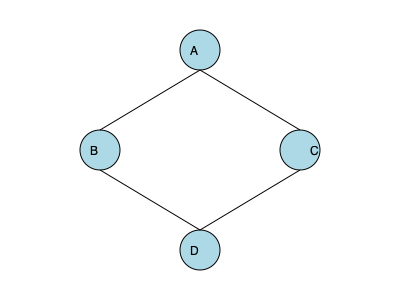Which network topology is represented in the diagram above, and how might it be beneficial for secure transmission of sensitive medical data? To identify the network topology and understand its benefits for secure medical data transmission, let's follow these steps:

1. Observe the diagram:
   - There are four nodes (A, B, C, and D) connected by lines.
   - The connections form a diamond shape.

2. Identify the topology:
   - This is a Ring topology, where each node is connected to exactly two other nodes, forming a closed loop.

3. Characteristics of a Ring topology:
   - Data travels in one direction around the ring.
   - Each node acts as a repeater, boosting the signal.

4. Benefits for secure medical data transmission:
   a) Redundancy: If one connection fails, data can still reach its destination through the other direction.
   b) Predictable performance: Each node gets an equal opportunity to transmit, ensuring consistent data flow.
   c) No central point of failure: Unlike star topologies, there's no central hub that could compromise the entire network if it fails.
   d) Easy to implement encryption: Data can be encrypted at each node before passing it on.
   e) Fault isolation: It's easy to isolate and identify issues in the network.

5. Relevance to medical data:
   - Ensures high availability of sensitive patient information.
   - Provides a consistent and reliable medium for real-time data transmission, crucial for medical emergencies.
   - Enhances security by allowing encryption at each node and eliminating a central vulnerable point.

The Ring topology offers a balance of reliability, performance, and security features that make it suitable for transmitting sensitive medical data in a secure manner.
Answer: Ring topology; offers redundancy, consistent performance, no central point of failure, and easy encryption implementation for secure medical data transmission. 